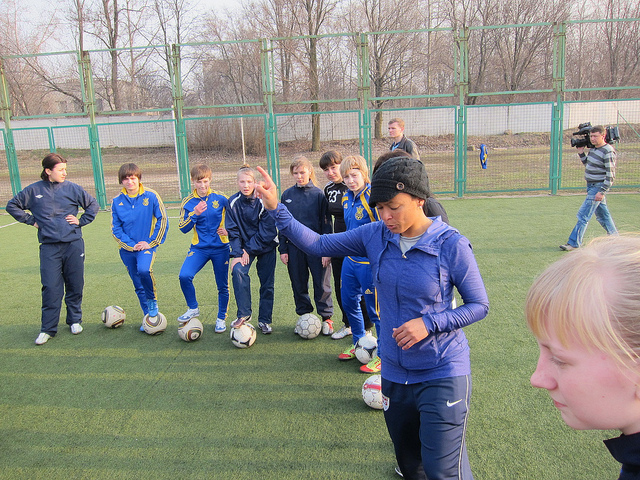Read and extract the text from this image. 23 